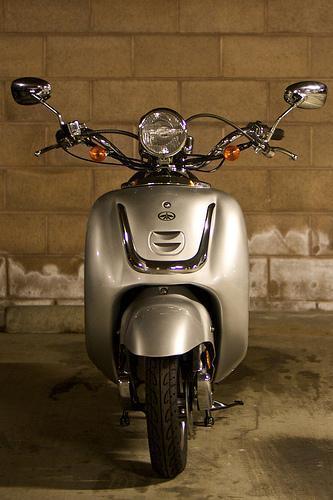How many scooters are there?
Give a very brief answer. 1. 